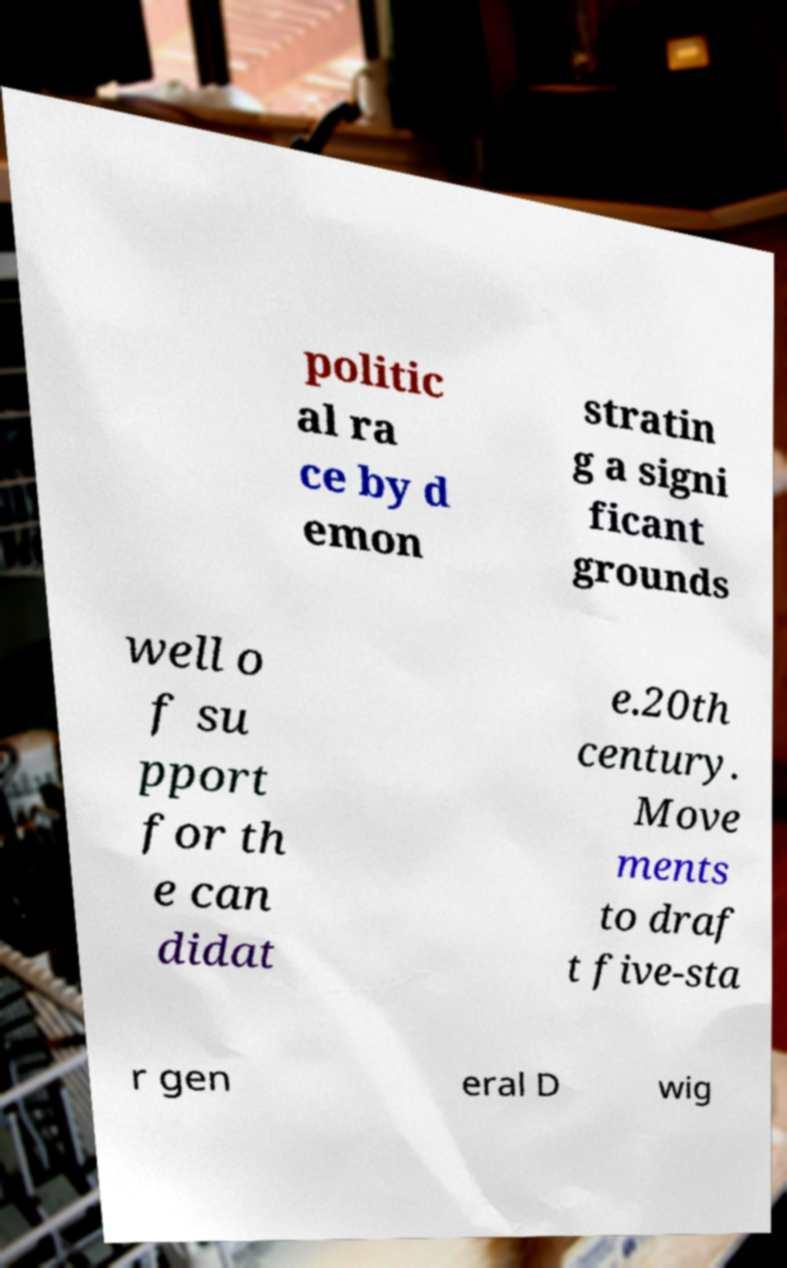I need the written content from this picture converted into text. Can you do that? politic al ra ce by d emon stratin g a signi ficant grounds well o f su pport for th e can didat e.20th century. Move ments to draf t five-sta r gen eral D wig 